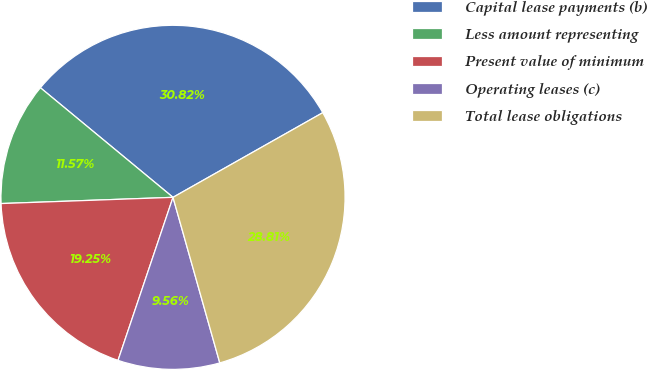<chart> <loc_0><loc_0><loc_500><loc_500><pie_chart><fcel>Capital lease payments (b)<fcel>Less amount representing<fcel>Present value of minimum<fcel>Operating leases (c)<fcel>Total lease obligations<nl><fcel>30.82%<fcel>11.57%<fcel>19.25%<fcel>9.56%<fcel>28.81%<nl></chart> 